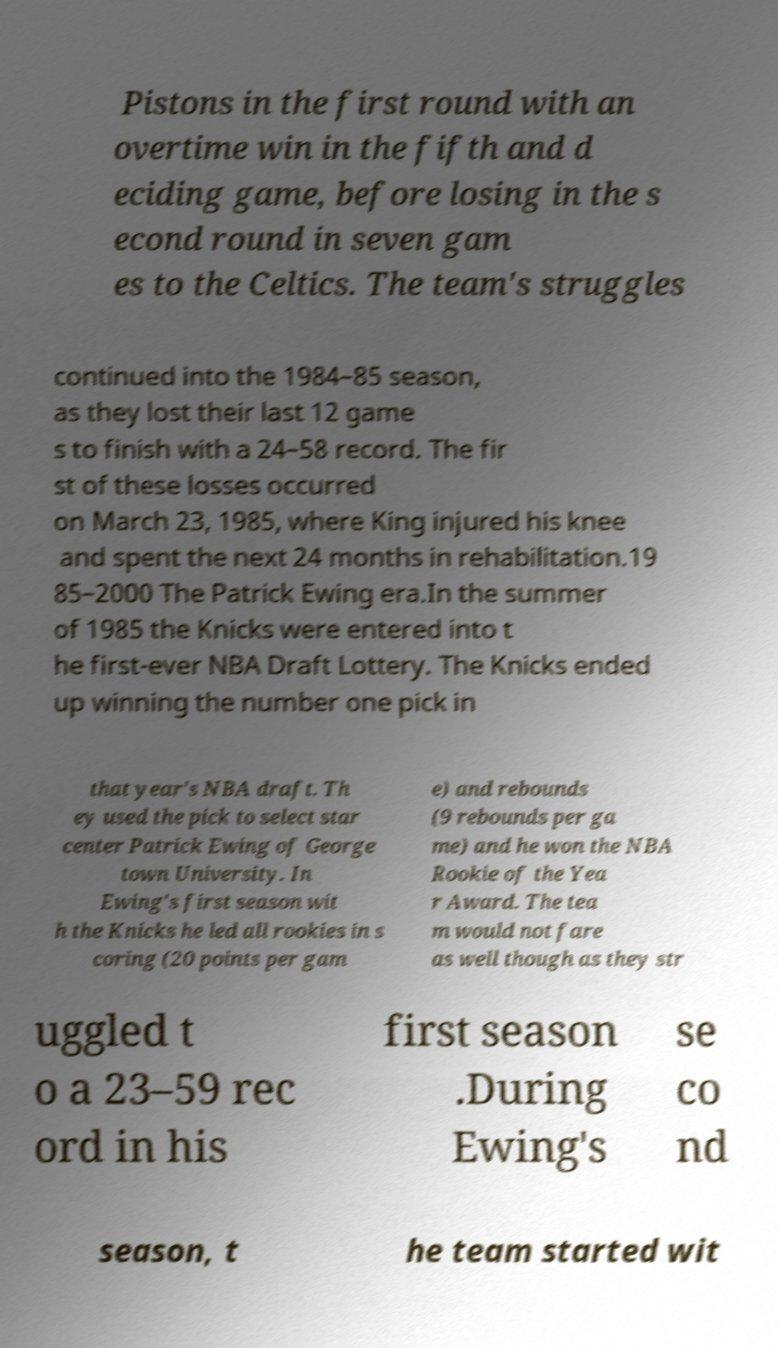Please read and relay the text visible in this image. What does it say? Pistons in the first round with an overtime win in the fifth and d eciding game, before losing in the s econd round in seven gam es to the Celtics. The team's struggles continued into the 1984–85 season, as they lost their last 12 game s to finish with a 24–58 record. The fir st of these losses occurred on March 23, 1985, where King injured his knee and spent the next 24 months in rehabilitation.19 85–2000 The Patrick Ewing era.In the summer of 1985 the Knicks were entered into t he first-ever NBA Draft Lottery. The Knicks ended up winning the number one pick in that year's NBA draft. Th ey used the pick to select star center Patrick Ewing of George town University. In Ewing's first season wit h the Knicks he led all rookies in s coring (20 points per gam e) and rebounds (9 rebounds per ga me) and he won the NBA Rookie of the Yea r Award. The tea m would not fare as well though as they str uggled t o a 23–59 rec ord in his first season .During Ewing's se co nd season, t he team started wit 